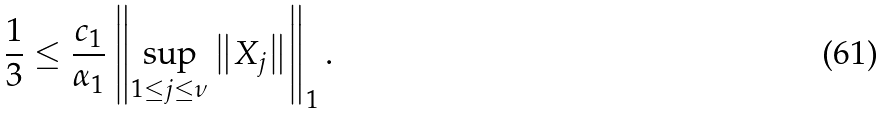<formula> <loc_0><loc_0><loc_500><loc_500>\frac { 1 } { 3 } \leq \frac { c _ { 1 } } { \alpha _ { 1 } } \left \| \sup _ { 1 \leq j \leq \nu } \left \| X _ { j } \right \| \right \| _ { 1 } .</formula> 